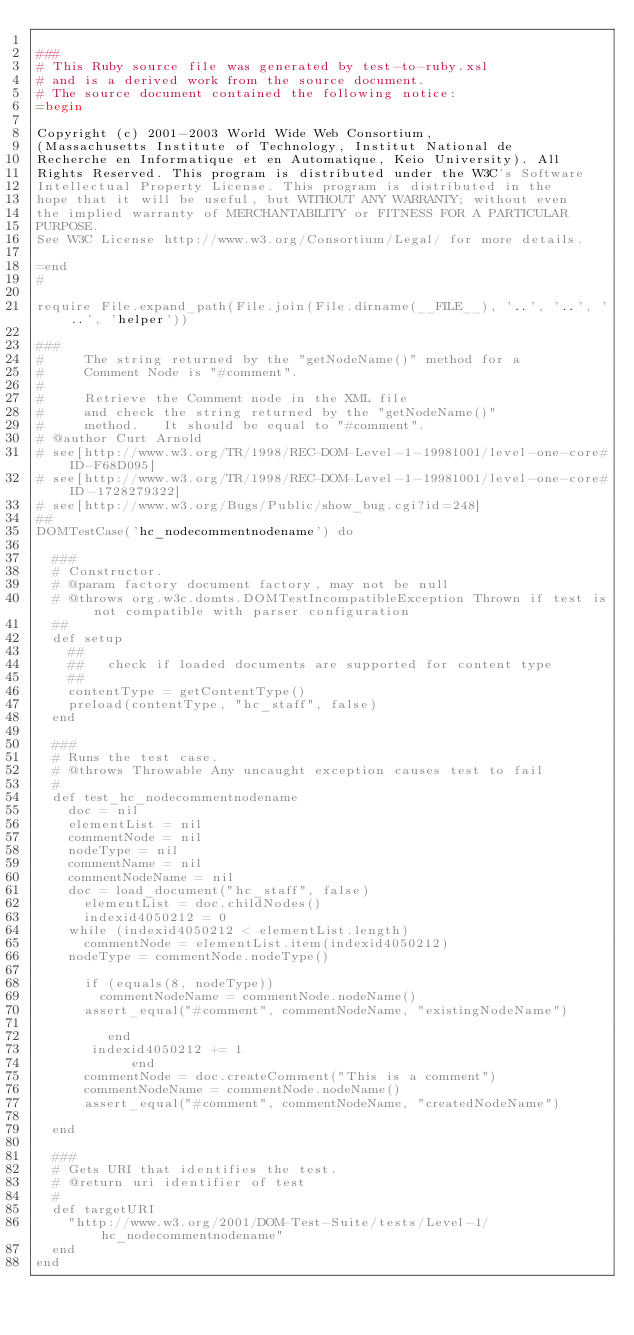<code> <loc_0><loc_0><loc_500><loc_500><_Ruby_>
###
# This Ruby source file was generated by test-to-ruby.xsl
# and is a derived work from the source document.
# The source document contained the following notice:
=begin

Copyright (c) 2001-2003 World Wide Web Consortium,
(Massachusetts Institute of Technology, Institut National de
Recherche en Informatique et en Automatique, Keio University). All
Rights Reserved. This program is distributed under the W3C's Software
Intellectual Property License. This program is distributed in the
hope that it will be useful, but WITHOUT ANY WARRANTY; without even
the implied warranty of MERCHANTABILITY or FITNESS FOR A PARTICULAR
PURPOSE.
See W3C License http://www.w3.org/Consortium/Legal/ for more details.

=end
#

require File.expand_path(File.join(File.dirname(__FILE__), '..', '..', '..', 'helper'))

###
#     The string returned by the "getNodeName()" method for a 
#     Comment Node is "#comment".
#     
#     Retrieve the Comment node in the XML file 
#     and check the string returned by the "getNodeName()" 
#     method.   It should be equal to "#comment".
# @author Curt Arnold
# see[http://www.w3.org/TR/1998/REC-DOM-Level-1-19981001/level-one-core#ID-F68D095]
# see[http://www.w3.org/TR/1998/REC-DOM-Level-1-19981001/level-one-core#ID-1728279322]
# see[http://www.w3.org/Bugs/Public/show_bug.cgi?id=248]
##
DOMTestCase('hc_nodecommentnodename') do

  ###
  # Constructor.
  # @param factory document factory, may not be null
  # @throws org.w3c.domts.DOMTestIncompatibleException Thrown if test is not compatible with parser configuration
  ##
  def setup
    ##
    ##   check if loaded documents are supported for content type
    ##
    contentType = getContentType()
    preload(contentType, "hc_staff", false)
  end

  ###
  # Runs the test case.
  # @throws Throwable Any uncaught exception causes test to fail
  #
  def test_hc_nodecommentnodename
    doc = nil
    elementList = nil
    commentNode = nil
    nodeType = nil
    commentName = nil
    commentNodeName = nil
    doc = load_document("hc_staff", false)
      elementList = doc.childNodes()
      indexid4050212 = 0
    while (indexid4050212 < elementList.length)
      commentNode = elementList.item(indexid4050212)
    nodeType = commentNode.nodeType()
      
      if (equals(8, nodeType))
        commentNodeName = commentNode.nodeName()
      assert_equal("#comment", commentNodeName, "existingNodeName")
            
         end
       indexid4050212 += 1
            end
      commentNode = doc.createComment("This is a comment")
      commentNodeName = commentNode.nodeName()
      assert_equal("#comment", commentNodeName, "createdNodeName")
            
  end

  ###
  # Gets URI that identifies the test.
  # @return uri identifier of test
  #
  def targetURI
    "http://www.w3.org/2001/DOM-Test-Suite/tests/Level-1/hc_nodecommentnodename"
  end
end

</code> 